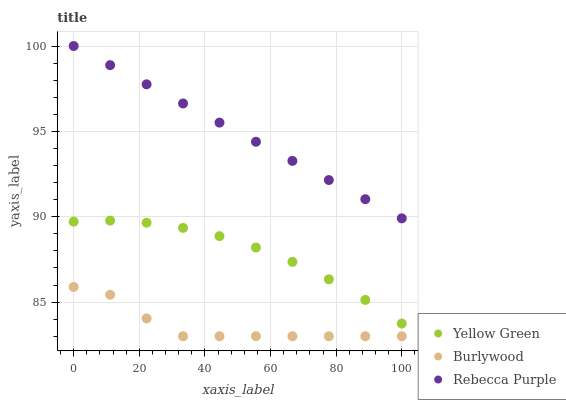Does Burlywood have the minimum area under the curve?
Answer yes or no. Yes. Does Rebecca Purple have the maximum area under the curve?
Answer yes or no. Yes. Does Yellow Green have the minimum area under the curve?
Answer yes or no. No. Does Yellow Green have the maximum area under the curve?
Answer yes or no. No. Is Rebecca Purple the smoothest?
Answer yes or no. Yes. Is Burlywood the roughest?
Answer yes or no. Yes. Is Yellow Green the smoothest?
Answer yes or no. No. Is Yellow Green the roughest?
Answer yes or no. No. Does Burlywood have the lowest value?
Answer yes or no. Yes. Does Yellow Green have the lowest value?
Answer yes or no. No. Does Rebecca Purple have the highest value?
Answer yes or no. Yes. Does Yellow Green have the highest value?
Answer yes or no. No. Is Burlywood less than Yellow Green?
Answer yes or no. Yes. Is Yellow Green greater than Burlywood?
Answer yes or no. Yes. Does Burlywood intersect Yellow Green?
Answer yes or no. No. 